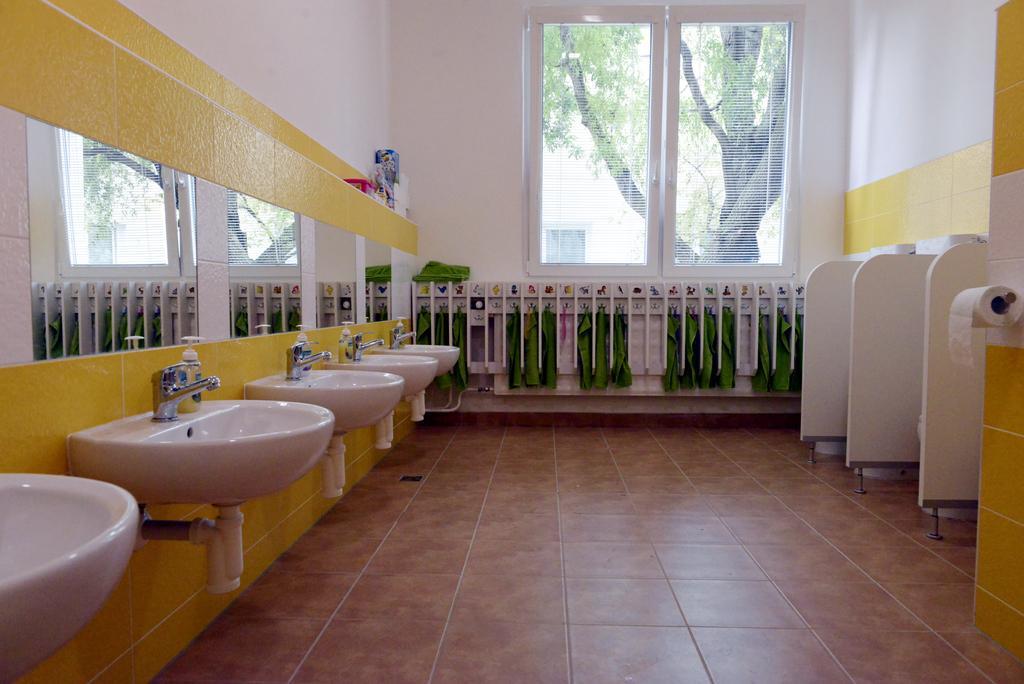In one or two sentences, can you explain what this image depicts? This picture is clicked inside. On the right corner we can see a toilet paper and in the center we can see the green color objects seems to be the towels hanging on the wall. On the left we can see the sinks, taps and bottles and we can see the wall mounted mirrors on which we can see the reflection of windows. In the background we can see the wall and some other objects and we can see the window and through the window we can see the building and the tree. 